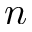<formula> <loc_0><loc_0><loc_500><loc_500>n</formula> 